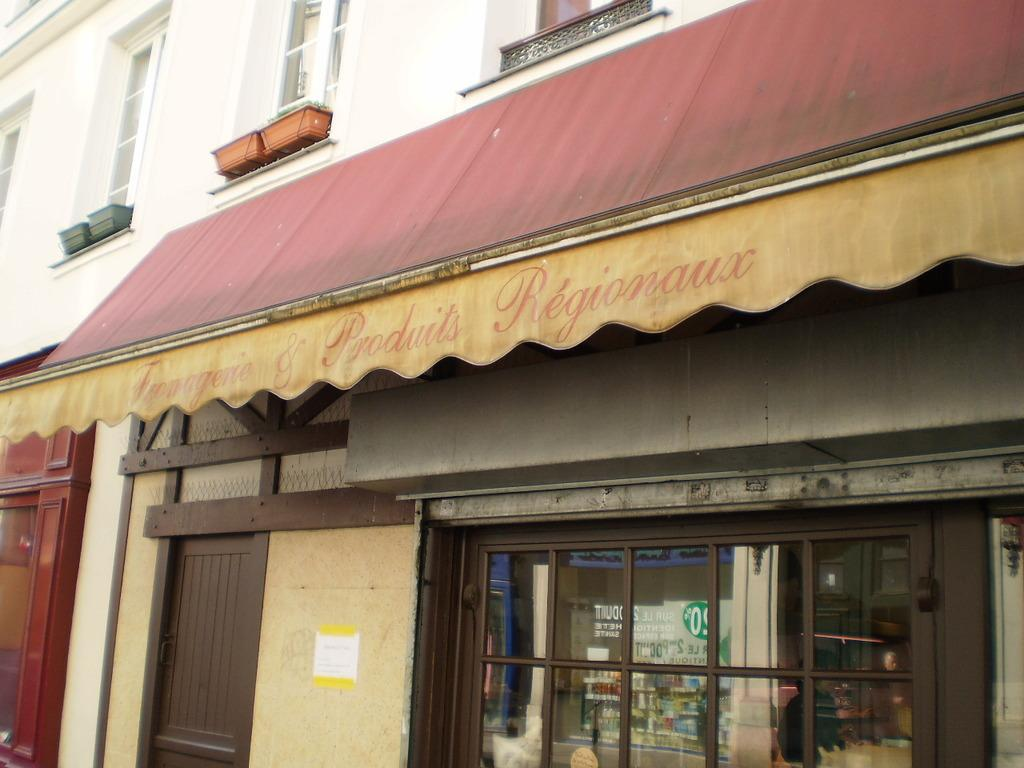What type of structures can be seen in the image? There are buildings in the image. What material is used for the walls of the buildings in the image? There are glass walls visible in the image. Can you see a toad engaging in any activity in the image? There is no toad present in the image, and therefore no such activity can be observed. What type of thread is being used to construct the buildings in the image? The buildings in the image are not constructed with thread; they have glass walls. 